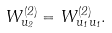<formula> <loc_0><loc_0><loc_500><loc_500>W ^ { ( 2 ) } _ { u _ { 2 } } = W ^ { ( 2 ) } _ { u _ { 1 } u _ { 1 } } .</formula> 